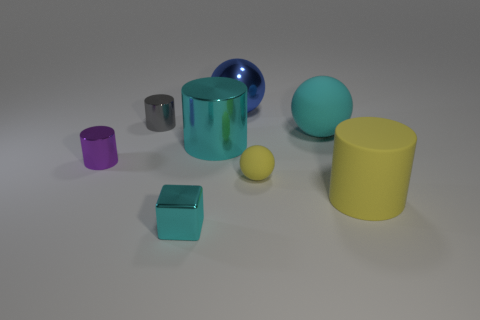Add 2 brown shiny balls. How many objects exist? 10 Subtract all blocks. How many objects are left? 7 Add 5 tiny yellow objects. How many tiny yellow objects exist? 6 Subtract 0 brown cubes. How many objects are left? 8 Subtract all yellow cylinders. Subtract all tiny objects. How many objects are left? 3 Add 4 tiny rubber balls. How many tiny rubber balls are left? 5 